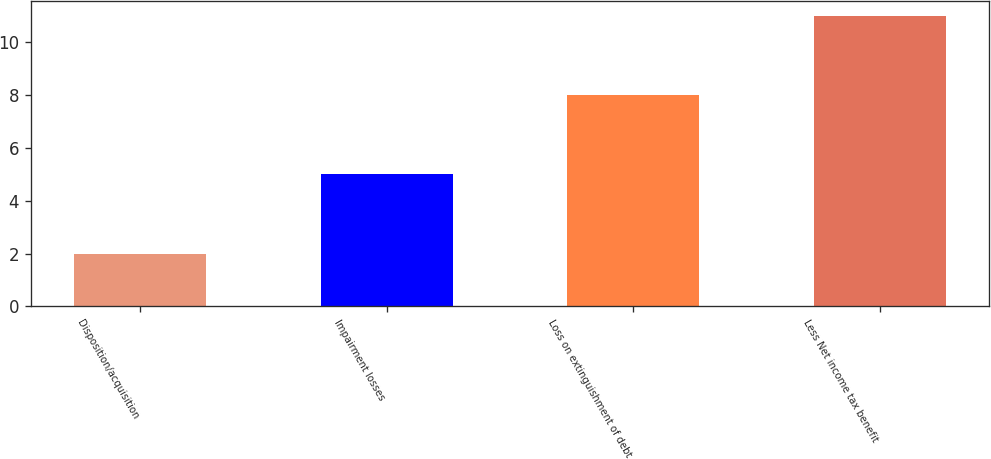Convert chart. <chart><loc_0><loc_0><loc_500><loc_500><bar_chart><fcel>Disposition/acquisition<fcel>Impairment losses<fcel>Loss on extinguishment of debt<fcel>Less Net income tax benefit<nl><fcel>2<fcel>5<fcel>8<fcel>11<nl></chart> 